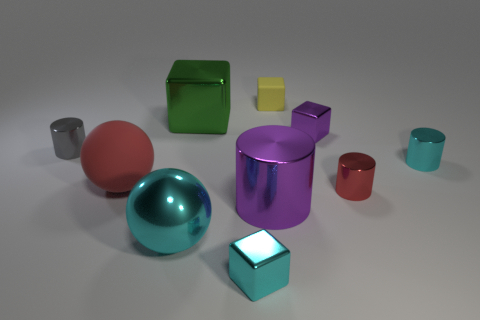There is a cyan thing that is the same shape as the gray shiny object; what is it made of?
Your response must be concise. Metal. The rubber block is what color?
Offer a very short reply. Yellow. What number of small matte things are right of the shiny block in front of the gray cylinder?
Offer a terse response. 1. What size is the shiny cube that is to the right of the large metal block and behind the cyan shiny cylinder?
Provide a succinct answer. Small. What is the material of the big purple cylinder that is in front of the tiny red object?
Your answer should be compact. Metal. Are there any purple metallic things of the same shape as the gray shiny thing?
Offer a very short reply. Yes. How many green metallic things have the same shape as the tiny gray object?
Your response must be concise. 0. Is the size of the purple metallic object behind the cyan cylinder the same as the purple object on the left side of the tiny purple shiny cube?
Offer a terse response. No. What shape is the tiny red thing that is in front of the tiny cyan metal object that is right of the small yellow block?
Make the answer very short. Cylinder. Are there the same number of large metal things right of the small red shiny thing and big cyan cubes?
Make the answer very short. Yes. 